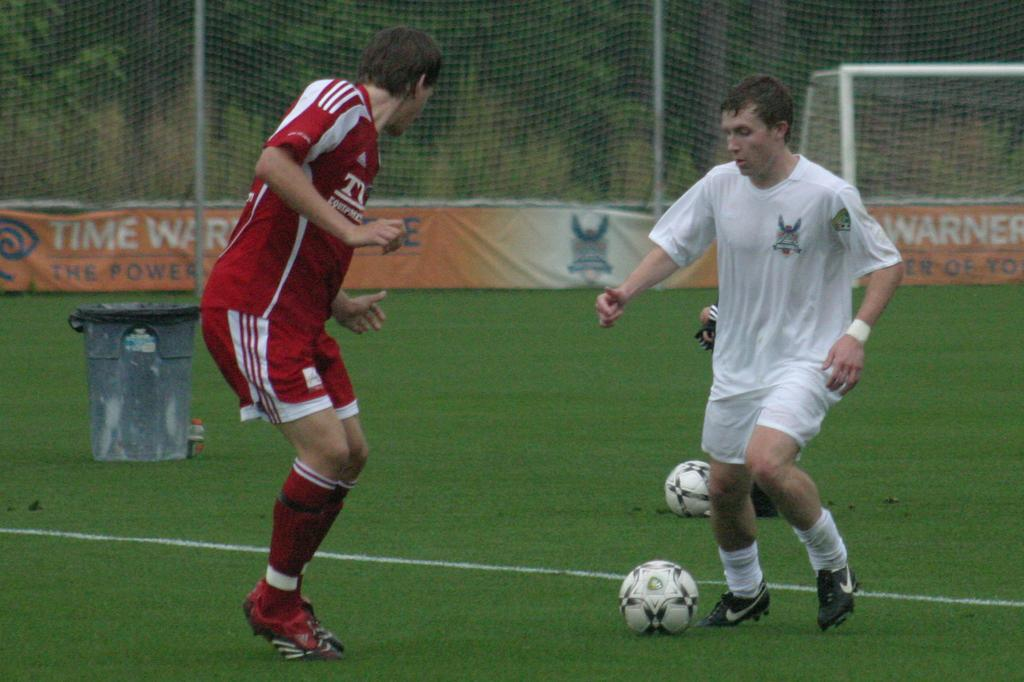<image>
Share a concise interpretation of the image provided. Two men face each other on a soccer field lined with Time Warner banners 